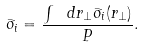Convert formula to latex. <formula><loc_0><loc_0><loc_500><loc_500>\bar { \sigma } _ { i } = \frac { \int \ d r _ { \perp } \bar { \sigma } _ { i } ( r _ { \perp } ) } { P } .</formula> 